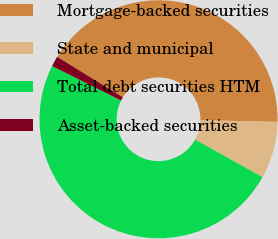Convert chart. <chart><loc_0><loc_0><loc_500><loc_500><pie_chart><fcel>Mortgage-backed securities<fcel>State and municipal<fcel>Total debt securities HTM<fcel>Asset-backed securities<nl><fcel>41.56%<fcel>7.73%<fcel>49.29%<fcel>1.41%<nl></chart> 